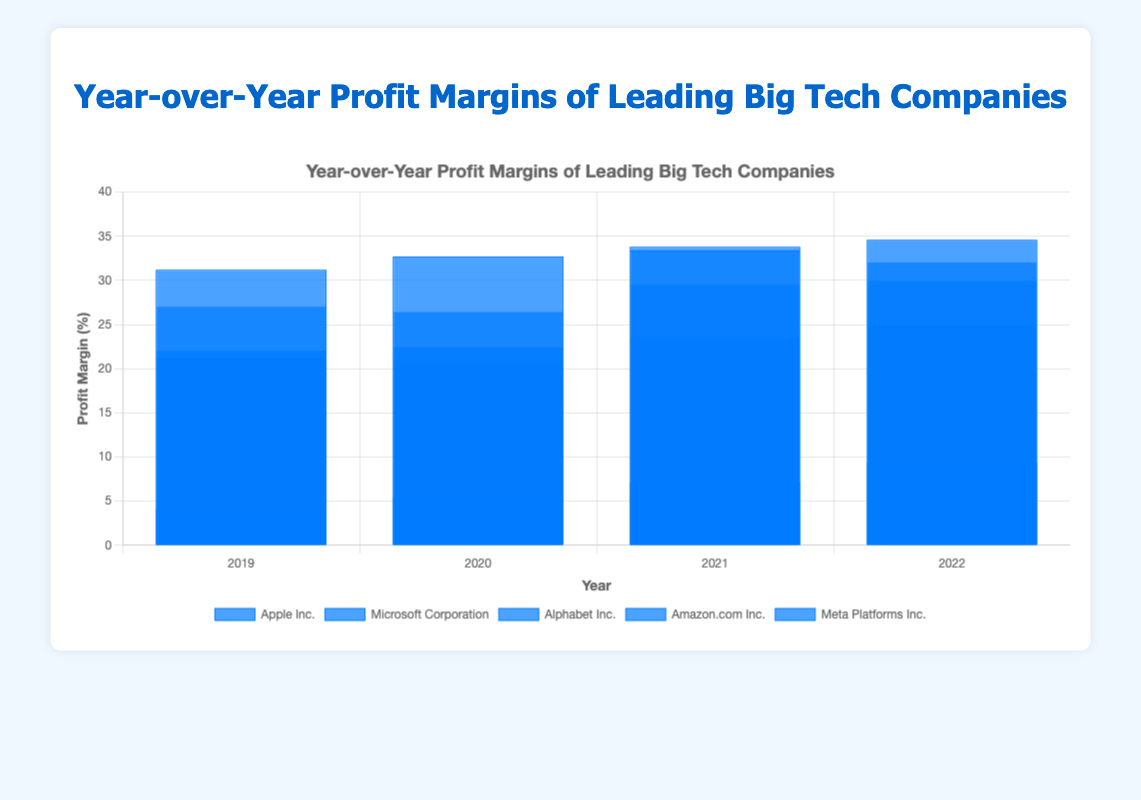What's the Year-over-Year profit margin trend for Microsoft Corporation from 2019 to 2022? To identify Microsoft Corporation's Year-over-Year profit margins from the chart, look at the series of blue bars labeled under Microsoft Corporation. The trend in percent values for the years 2019 to 2022 is: 2019 (31.2%), 2020 (32.7%), 2021 (33.8%), and 2022 (34.6%). Thus, Microsoft Corporation's profit margins have been increasing over the years.
Answer: Increasing Which company had the highest profit margin in 2022? To determine the company with the highest profit margin in 2022, compare the height of blue bars for all companies for the year 2022. Microsoft Corporation has the tallest bar representing a profit margin of 34.6%, which is the highest among the listed companies for 2022.
Answer: Microsoft Corporation Which company shows the most significant increase in profit margins between 2019 and 2022? To find the company with the most significant increase in profit margins, calculate the difference between the 2019 and 2022 profit margins for each company. 
- Apple Inc.: 25.0% - 21.2% = 3.8%
- Microsoft Corporation: 34.6% - 31.2% = 3.4%
- Alphabet Inc.: 32.0% - 22.0% = 10.0%
- Amazon.com Inc.: 9.4% - 4.1% = 5.3%
- Meta Platforms Inc.: 29.9% - 27.0% = 2.9%
Alphabet Inc. shows the most significant increase with a change of 10.0%.
Answer: Alphabet Inc What is the average profit margin of Apple Inc. from 2019 to 2022? To calculate the average profit margin of Apple Inc., sum their yearly profit margins from the chart and divide by the number of years. The sum is 21.2% + 20.9% + 23.4% + 25.0% = 90.5%. Dividing by 4, the average profit margin is 90.5/4 = 22.625%.
Answer: 22.625% How do the profit margins of Meta Platforms Inc. compare from 2021 to 2022? Compare the heights of the blue bars for Meta Platforms Inc. between 2021 and 2022. The profit margins are 33.4% in 2021 and 29.9% in 2022, indicating a decrease.
Answer: Decrease Which company had the lowest profit margin in 2021? To find the lowest profit margin in 2021, compare the heights of the blue bars for all companies in 2021. Amazon.com Inc.'s bar is the shortest, suggesting a 7.1% profit margin, which is the lowest among the companies.
Answer: Amazon.com Inc What's the total profit margin for Alphabet Inc. over the four years 2019 to 2022? To find the total profit margin for Alphabet Inc. over the four years, sum their yearly profit margins as depicted in the chart: 22.0% + 22.4% + 29.5% + 32.0% = 105.9%.
Answer: 105.9% How did Amazon.com's profit margin change from 2019 to 2022? Look at the series of blue bars for Amazon.com Inc. from 2019 to 2022 and calculate the change: 4.1% in 2019, increasing through 5.5% (2020), 7.1% (2021), and reaching 9.4% in 2022. The difference is 9.4% - 4.1% = 5.3%.
Answer: Increased by 5.3% Which company experienced a decrease in profit margin between 2021 and 2022? Compare the blue bars for 2021 and 2022 for each company. Meta Platforms Inc. shows a decrease from 33.4% in 2021 to 29.9% in 2022.
Answer: Meta Platforms Inc What is the Year-over-Year profit margin growth for Apple Inc. from 2020 to 2021? Subtract Apple Inc.'s profit margin for 2020 (20.9%) from 2021 (23.4%) to find the growth. 23.4% - 20.9% = 2.5%.
Answer: 2.5% 